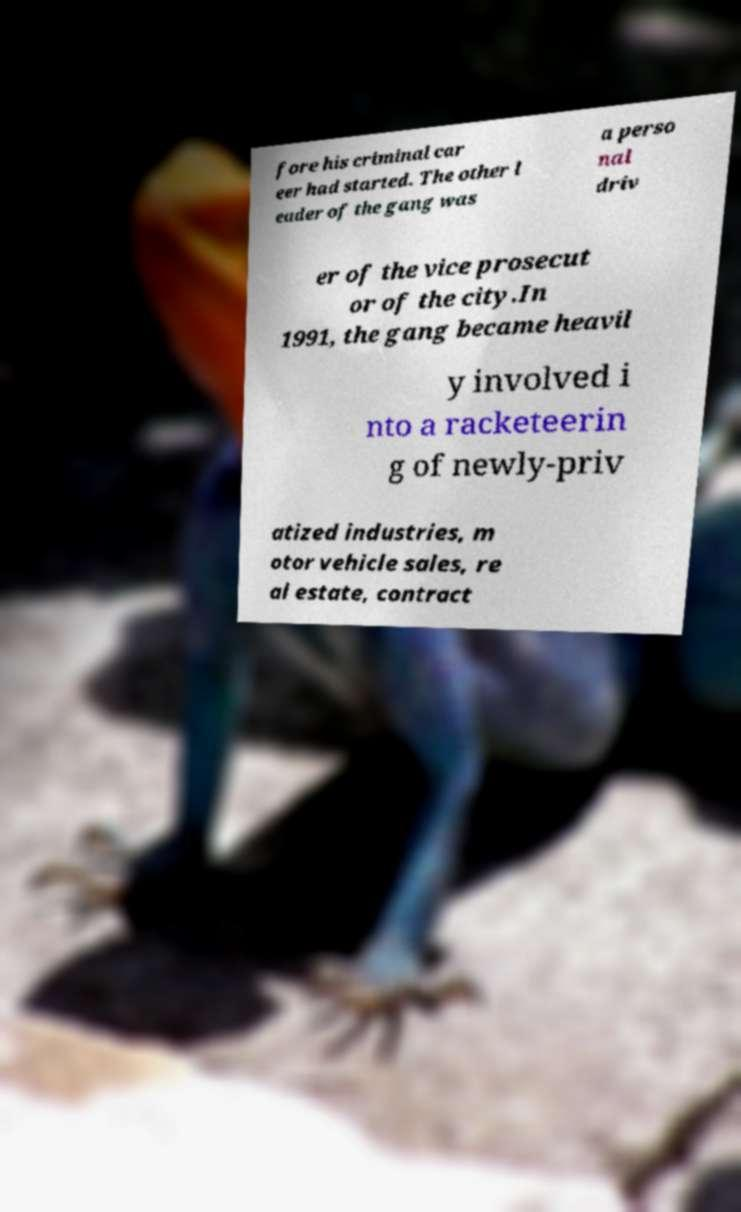There's text embedded in this image that I need extracted. Can you transcribe it verbatim? fore his criminal car eer had started. The other l eader of the gang was a perso nal driv er of the vice prosecut or of the city.In 1991, the gang became heavil y involved i nto a racketeerin g of newly-priv atized industries, m otor vehicle sales, re al estate, contract 